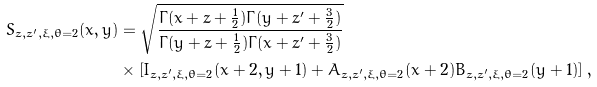<formula> <loc_0><loc_0><loc_500><loc_500>S _ { z , z ^ { \prime } , \xi , \theta = 2 } ( x , y ) & = \sqrt { \frac { \Gamma ( x + z + \frac { 1 } { 2 } ) \Gamma ( y + z ^ { \prime } + \frac { 3 } { 2 } ) } { \Gamma ( y + z + \frac { 1 } { 2 } ) \Gamma ( x + z ^ { \prime } + \frac { 3 } { 2 } ) } } \\ & \times \left [ I _ { z , z ^ { \prime } , \xi , \theta = 2 } ( x + 2 , y + 1 ) + A _ { z , z ^ { \prime } , \xi , \theta = 2 } ( x + 2 ) B _ { z , z ^ { \prime } , \xi , \theta = 2 } ( y + 1 ) \right ] ,</formula> 